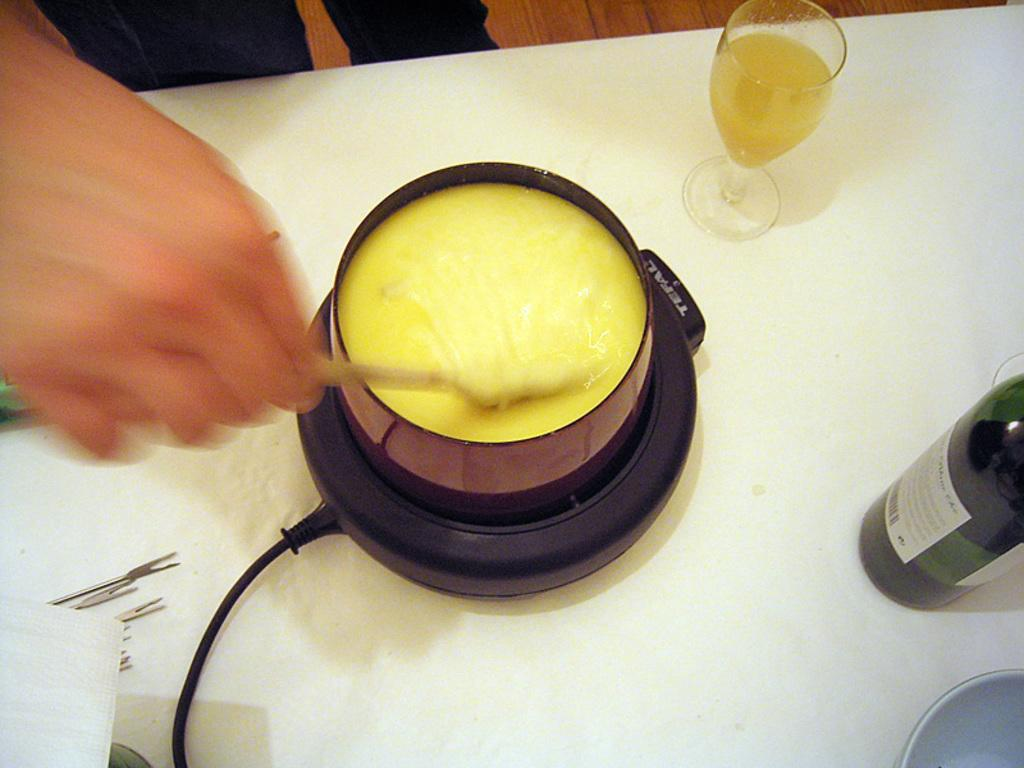What is the person holding in the image? The person is holding a spoon in the image. What type of container is visible in the image? There is a cup, a glass, a bowl, and a bottle in the image. What other objects can be seen on the table in the image? There are other objects on the table in the image, but their specific details are not mentioned in the provided facts. How does the person express anger in the image? There is no indication of anger in the image; the person is simply holding a spoon. Can you tell me how many cannons are present in the image? There are no cannons present in the image. 